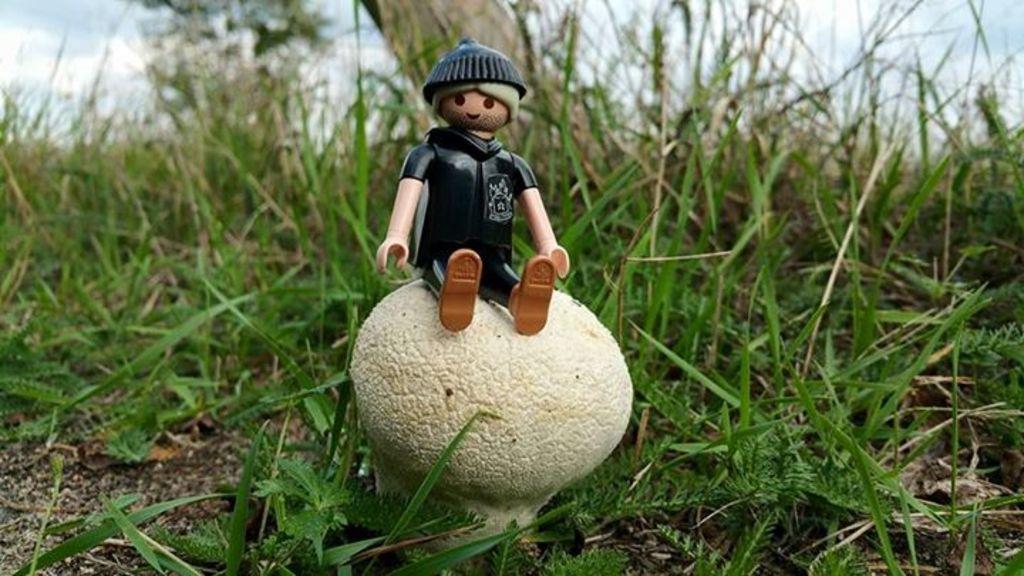Describe this image in one or two sentences. This picture is taken from outside of the city. In this image, in the middle, we can see a mushroom, on the mushroom, we can see a toy sitting. In the background, we can see some trees. At the top, we can see a sky, at the bottom, we can see a grass. 